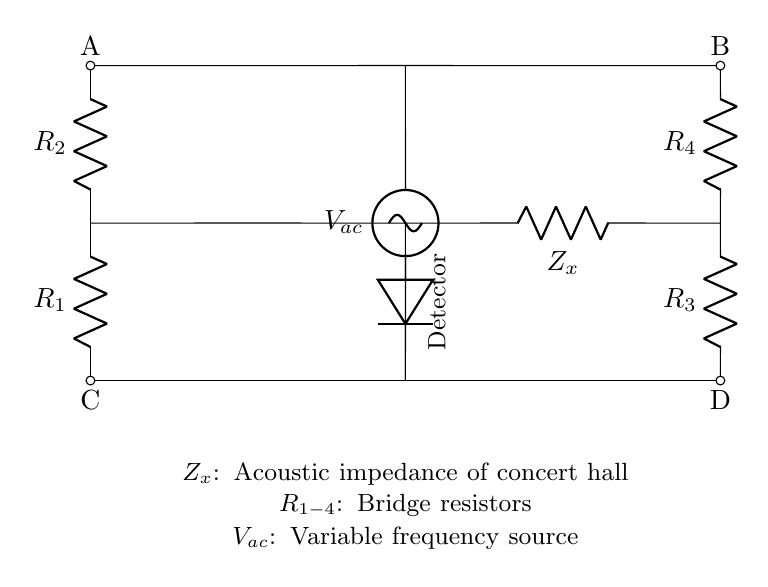What does Z_x represent in this circuit? Z_x represents the acoustic impedance of the concert hall being measured in this bridge circuit. It is the unknown component that the bridge circuit is designed to measure the response of.
Answer: Acoustic impedance How many resistors are present in the bridge? There are four resistors labeled as R_1, R_2, R_3, and R_4 in the circuit diagram, which form the arms of the bridge.
Answer: Four What does the variable frequency source provide? The variable frequency source provides an alternating current voltage, denoted as V_ac, which is essential for testing the frequency response of the acoustic space.
Answer: Alternating current voltage What is the purpose of the detector in this circuit? The detector is used to measure the difference in potential or output across the bridge circuit to determine how the acoustic impedance affects the overall frequency response.
Answer: Measure output How do the resistors affect the bridge circuit? The resistors play a critical role in balancing the bridge circuit. The values of the resistors will dictate when the bridge is in balance, impacting the measurement of Z_x across the detector.
Answer: Balance measurements What is the connection between points A and B? Points A and B are connected by the source V_ac providing voltage, creating a potential difference that drives the current through the bridge and resonates with the acoustic impedance.
Answer: Voltage source connection 